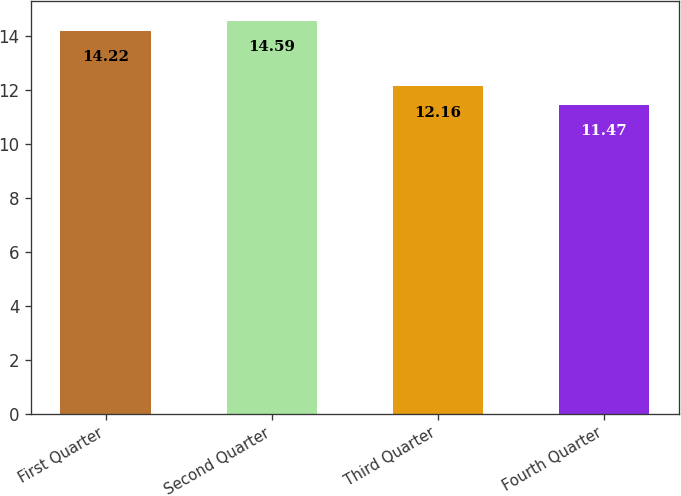<chart> <loc_0><loc_0><loc_500><loc_500><bar_chart><fcel>First Quarter<fcel>Second Quarter<fcel>Third Quarter<fcel>Fourth Quarter<nl><fcel>14.22<fcel>14.59<fcel>12.16<fcel>11.47<nl></chart> 